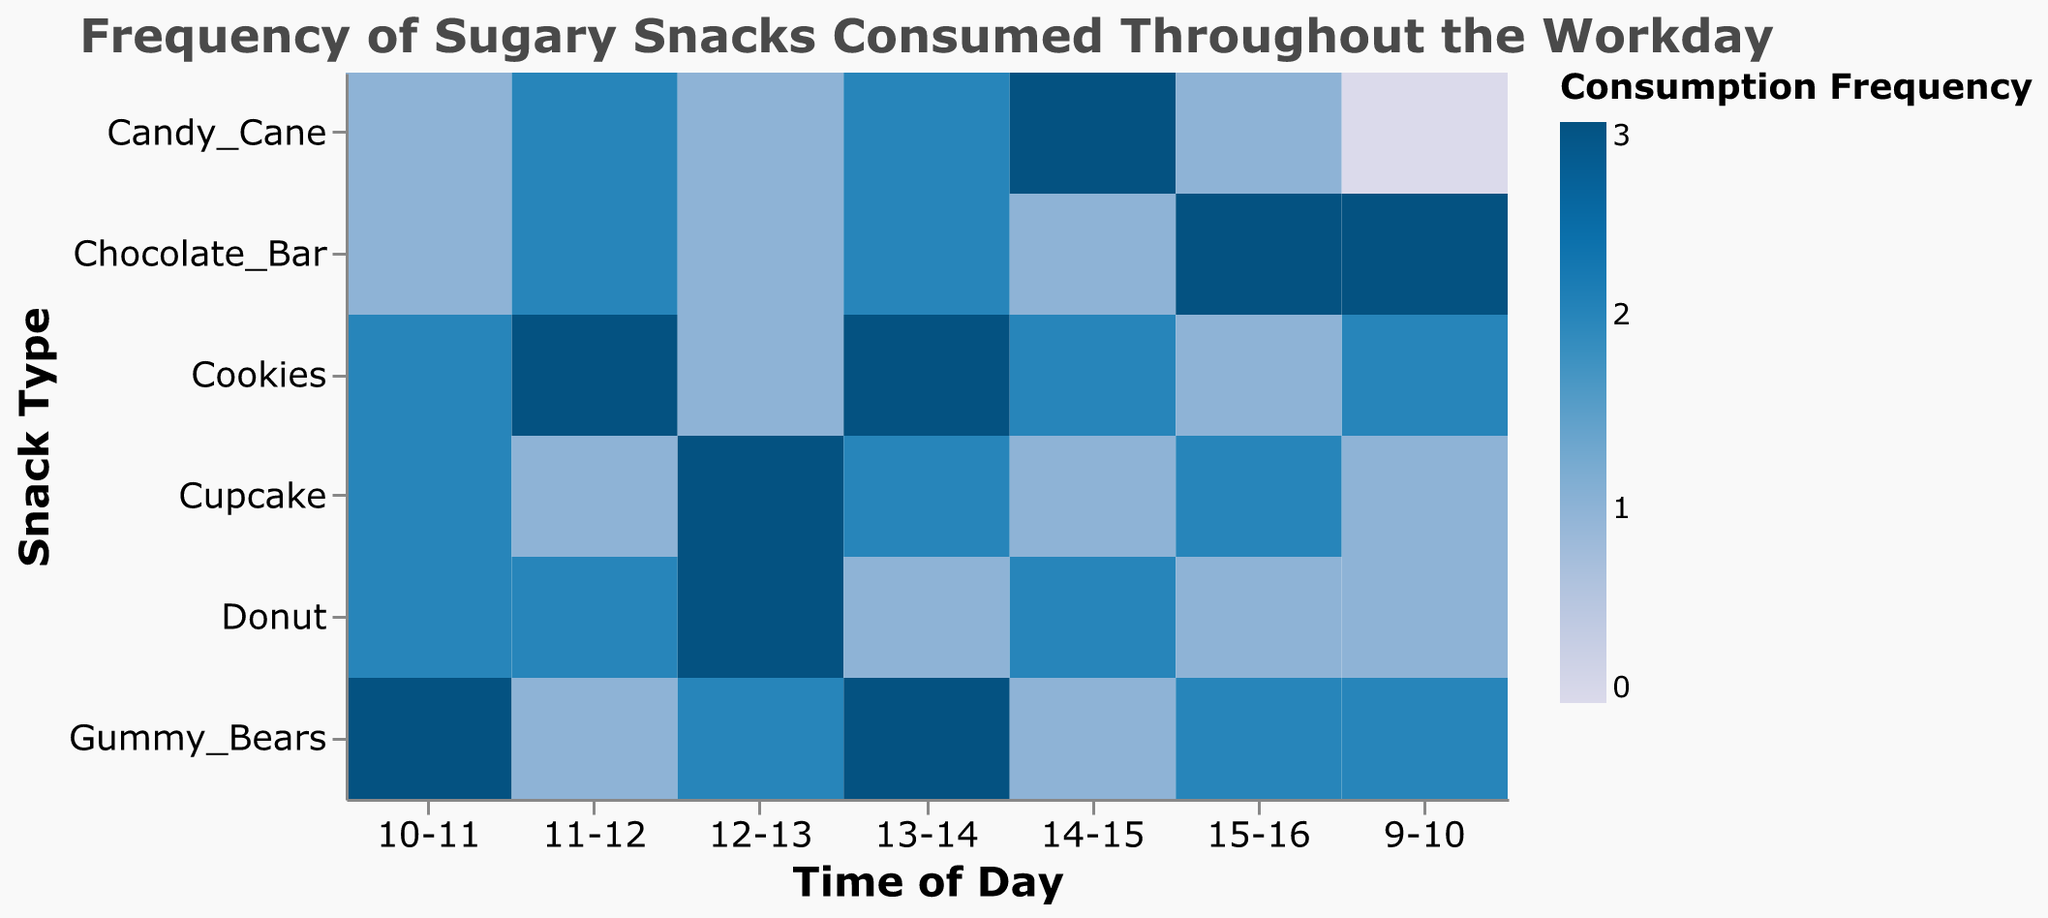What's the title of the figure? The title is the first piece of textual information displayed prominently at the top of the figure. It's usually written in a larger font size and describes the overall content of the figure.
Answer: Frequency of Sugary Snacks Consumed Throughout the Workday Which snack has the highest consumption in the first hour (9-10)? Look at the first column (Hour_9_10) and identify the snack with the highest frequency value. The highest value is 3, which corresponds to Chocolate_Bar.
Answer: Chocolate_Bar What is the total frequency of cupcake consumption throughout the day? Sum the frequencies for Cupcake across all hours. The values are 1, 2, 1, 3, 2, 1, 2. Total is 1+2+1+3+2+1+2 = 12.
Answer: 12 Which two hours have the highest consumption of candy canes? For Candy_Cane, compare the frequency values across all hours. The highest values are in Hour_14_15 and Hour_11_12, both with a frequency of 3 and 2 respectively.
Answer: 14-15 and 11-12 Compare the frequency of chocolate bars and cookies between 13-14. Which is higher? Look at the values in the column for Hour_13_14 for both snacks. Chocolate_Bar has a frequency of 2, while Cookies have a frequency of 3. Therefore, Cookies is higher.
Answer: Cookies What snack has the lowest overall consumption in the hour from 12-13? Check the column for Hour_12_13 to find the lowest value. The frequencies are 1 for Chocolate_Bar, Cupcake, and Candy_Cane.
Answer: Chocolate_Bar, Cupcake, Candy_Cane Calculate the average frequency of donuts consumed across all hours. Sum the frequencies for Donut (1, 2, 2, 3, 1, 2, 1) and divide by the number of hours. The sum is 1+2+2+3+1+2+1 = 12, and the average is 12 / 7 = approximately 1.71.
Answer: 1.71 In which hour is the consumption of sugary snacks the most balanced (least variance)? Assess the variation in consumption frequencies for each hour. The hour with the values closest to each other in each snack category is Hour_12_13 (1, 2, 3, 1, 3, 2), implying more balanced consumption.
Answer: 12-13 